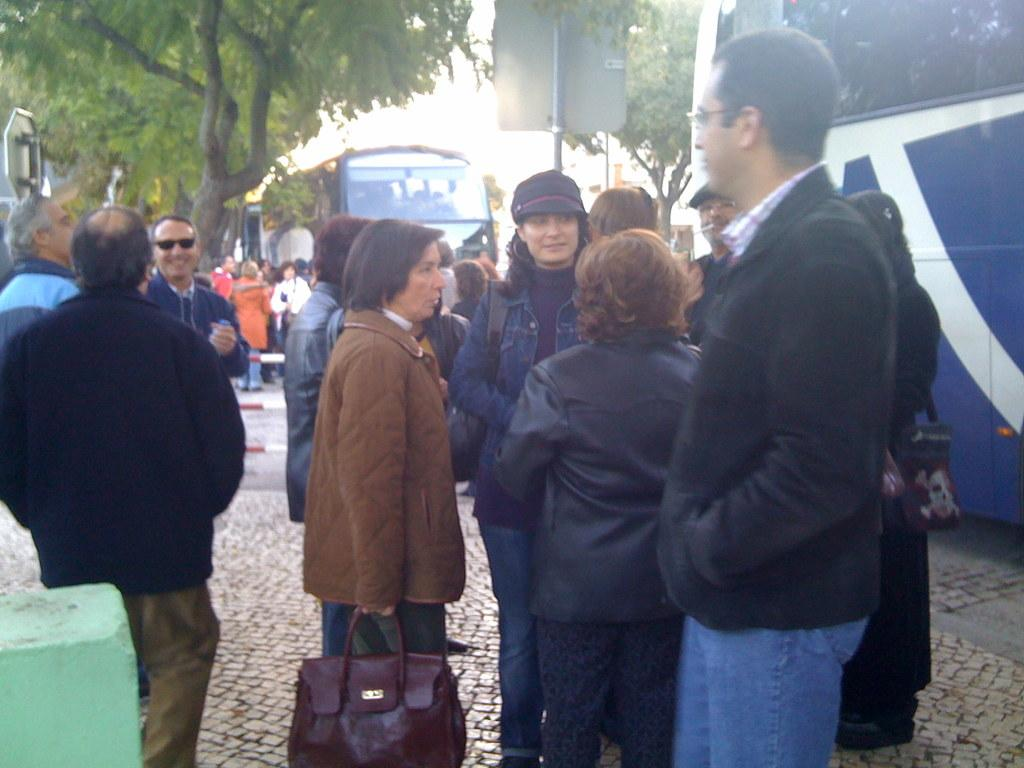What are the people in the image doing? There is a group of people standing in the image. Can you describe what one person is holding? One person is holding a bag. What else can be seen in the image besides the people? There are vehicles and trees visible in the image. What is visible in the background of the image? The sky is visible in the image. What type of wood is being used to build the sink in the image? There is no sink present in the image, and therefore no wood being used for it. 